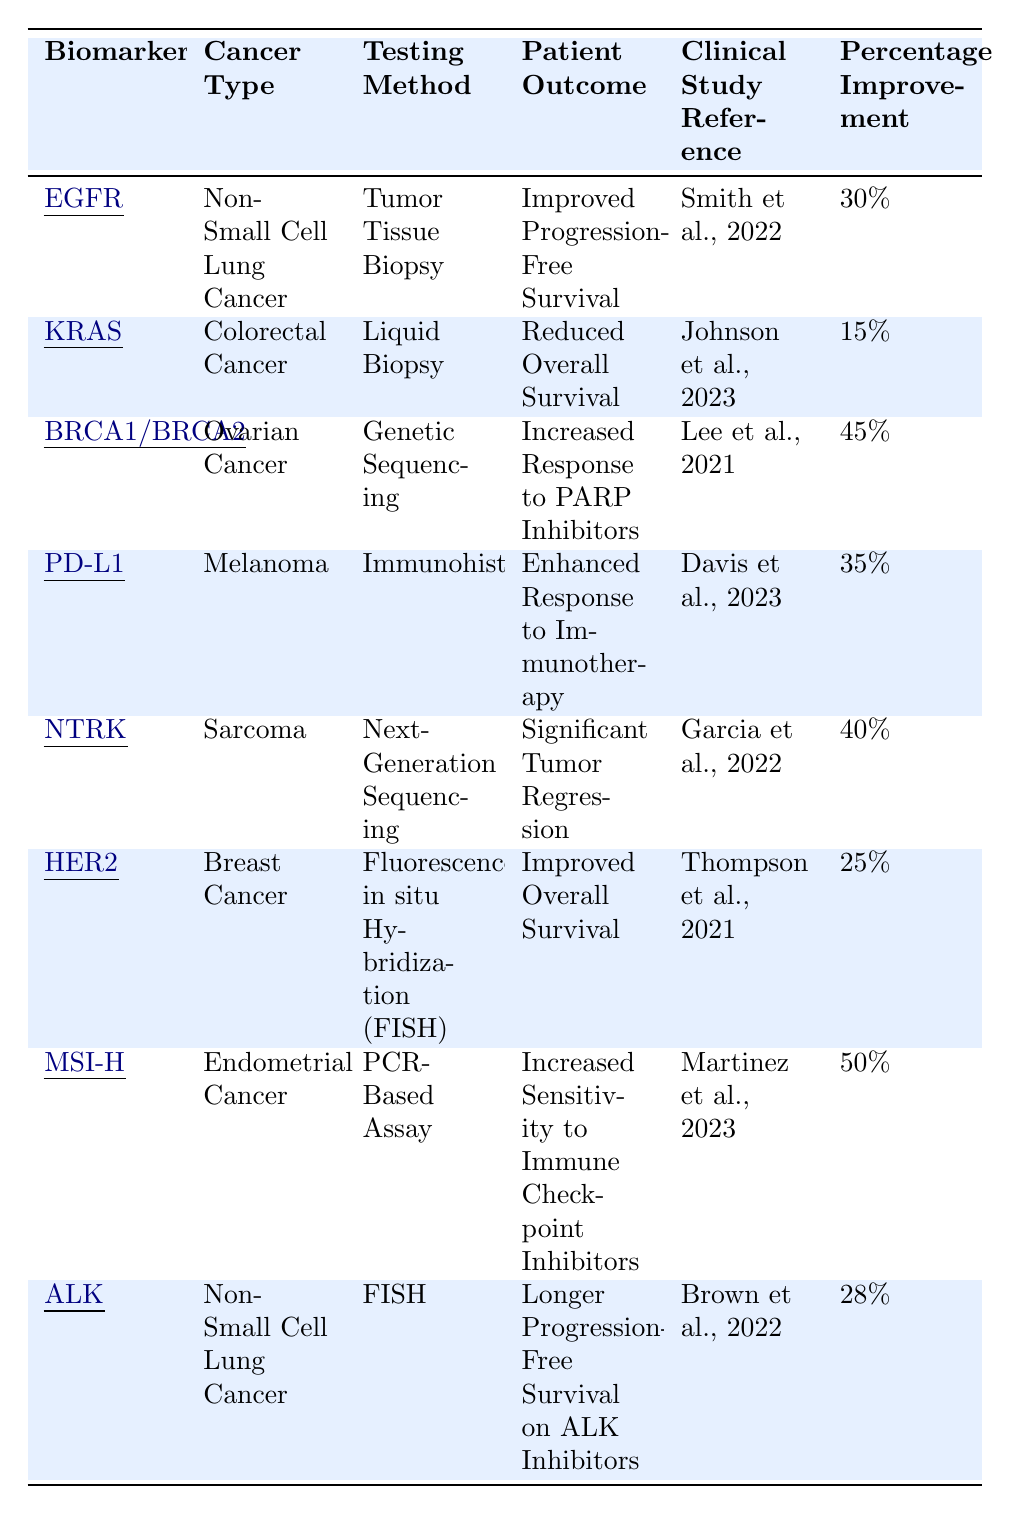What is the total percentage improvement from the patient outcomes listed in the table? The percentage improvements are 30%, 15%, 45%, 35%, 40%, 25%, 50%, and 28%. Adding these together gives: 30 + 15 + 45 + 35 + 40 + 25 + 50 + 28 = 268.
Answer: 268% Which biomarker shows the highest percentage improvement? Scanning the table, the highest percentage improvement listed is for MSI-H, which shows 50%.
Answer: MSI-H Is there any biomarker associated with reduced overall survival? Yes, KRAS shows a patient outcome of reduced overall survival.
Answer: Yes Which cancer type has the least percentage improvement? The percentage improvements for the cancer types are 30%, 15%, 45%, 35%, 40%, 25%, 50%, and 28%. The lowest value is 15%, corresponding to the colorectal cancer with KRAS.
Answer: Colorectal Cancer (KRAS) How do the patient outcomes for non-small cell lung cancer differ in terms of percentage improvement? The outcomes for non-small cell lung cancer are 30% for EGFR and 28% for ALK. The difference in their percentage improvement is 30% - 28% = 2%.
Answer: 2% What proportion of cancers listed demonstrate improved survival outcomes? The patient outcomes for improved survival are "Improved Progression-Free Survival" (EGFR), "Improved Overall Survival" (HER2), whereas "Reduced Overall Survival" (KRAS) indicates negative outcome. Thus, 3 out of 8 outcomes show improvement, giving a proportion of 3/8.
Answer: 3/8 Is the testing method for NTRK the same as for BRCA1/BRCA2? No, NTRK uses Next-Generation Sequencing while BRCA1/BRCA2 uses Genetic Sequencing.
Answer: No Which biomarker applied in endometrial cancer has improved patient outcomes, and what is the percentage? The biomarker MSI-H is associated with endometrial cancer and indicates increased sensitivity to immune checkpoint inhibitors with a percentage improvement of 50%.
Answer: MSI-H, 50% Which testing method seems most prevalent among the biomarkers listed? The testing methods are Tumor Tissue Biopsy, Liquid Biopsy, Genetic Sequencing, Immunohistochemistry, Next-Generation Sequencing, Fluorescence in situ Hybridization (FISH), and PCR-Based Assay. Since there is no repetition in methods, no method stands out as prevalent.
Answer: None What is the clinical study reference for the biomarker associated with the enhanced response to immunotherapy? The reference for PD-L1, which indicates enhanced response to immunotherapy, is Davis et al., 2023.
Answer: Davis et al., 2023 What is the combined percentage improvement of the breast cancer and ovarian cancer biomarkers? The percentage improvement for HER2 (breast cancer) is 25% and for BRCA1/BRCA2 (ovarian cancer) is 45%. Adding these gives: 25% + 45% = 70%.
Answer: 70% 